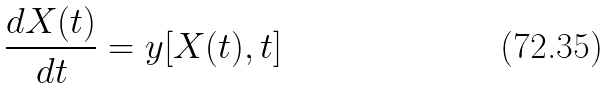Convert formula to latex. <formula><loc_0><loc_0><loc_500><loc_500>\frac { d X ( t ) } { d t } = y [ X ( t ) , t ]</formula> 